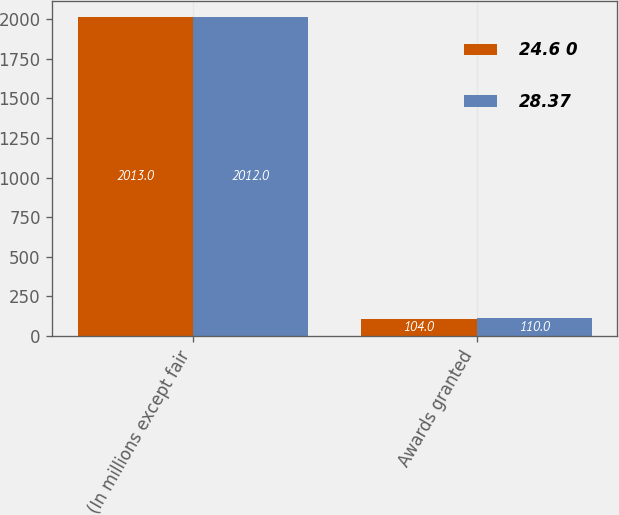Convert chart. <chart><loc_0><loc_0><loc_500><loc_500><stacked_bar_chart><ecel><fcel>(In millions except fair<fcel>Awards granted<nl><fcel>24.6 0<fcel>2013<fcel>104<nl><fcel>28.37<fcel>2012<fcel>110<nl></chart> 